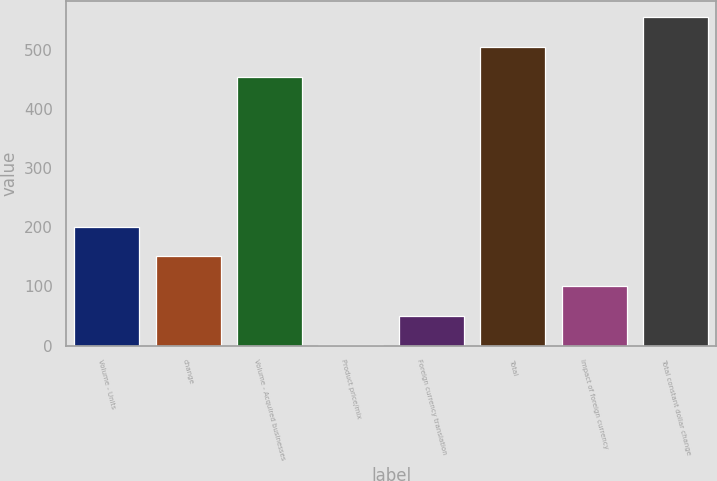Convert chart. <chart><loc_0><loc_0><loc_500><loc_500><bar_chart><fcel>Volume - Units<fcel>change<fcel>Volume - Acquired businesses<fcel>Product price/mix<fcel>Foreign currency translation<fcel>Total<fcel>Impact of foreign currency<fcel>Total constant dollar change<nl><fcel>200.82<fcel>150.74<fcel>455.3<fcel>0.5<fcel>50.58<fcel>505.38<fcel>100.66<fcel>555.46<nl></chart> 